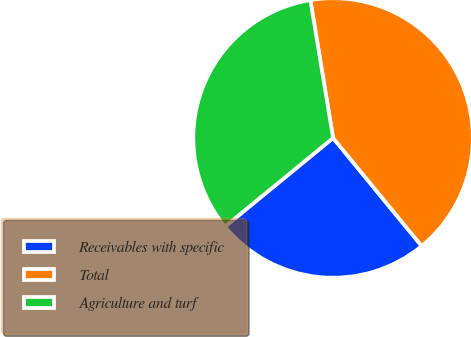Convert chart. <chart><loc_0><loc_0><loc_500><loc_500><pie_chart><fcel>Receivables with specific<fcel>Total<fcel>Agriculture and turf<nl><fcel>25.0%<fcel>41.67%<fcel>33.33%<nl></chart> 